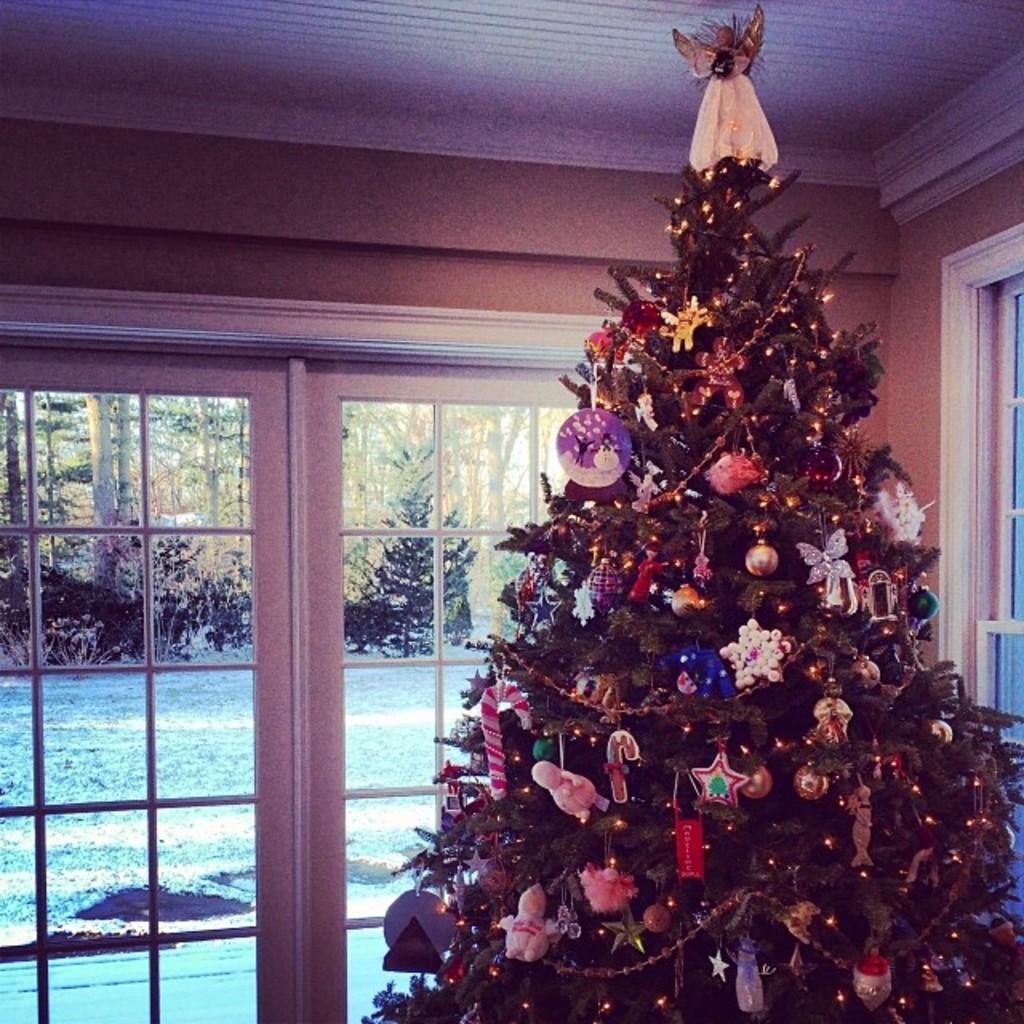What is located on the right side of the image? There is a Christmas tree on the right side of the image. How is the Christmas tree decorated? The Christmas tree is decorated. What can be seen behind the Christmas tree? There is a window behind the Christmas tree. What is visible through the window? Water and trees are visible through the window. What type of parcel is being delivered to the achiever in the image? There is no parcel or achiever present in the image; it features a decorated Christmas tree and a view through a window. 